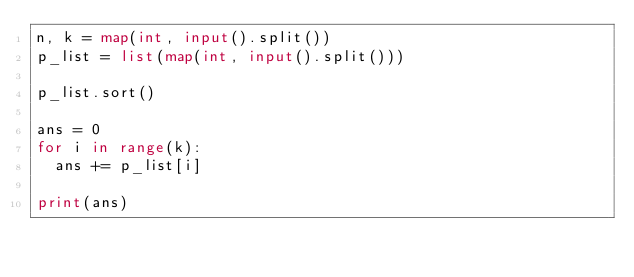Convert code to text. <code><loc_0><loc_0><loc_500><loc_500><_Python_>n, k = map(int, input().split())
p_list = list(map(int, input().split()))

p_list.sort()

ans = 0
for i in range(k):
  ans += p_list[i]
  
print(ans)</code> 